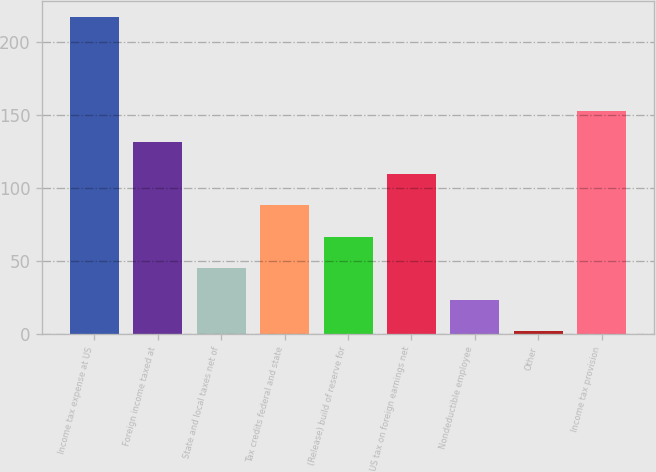<chart> <loc_0><loc_0><loc_500><loc_500><bar_chart><fcel>Income tax expense at US<fcel>Foreign income taxed at<fcel>State and local taxes net of<fcel>Tax credits federal and state<fcel>(Release) build of reserve for<fcel>US tax on foreign earnings net<fcel>Nondeductible employee<fcel>Other<fcel>Income tax provision<nl><fcel>217.8<fcel>131.48<fcel>45.16<fcel>88.32<fcel>66.74<fcel>109.9<fcel>23.58<fcel>2<fcel>153.06<nl></chart> 